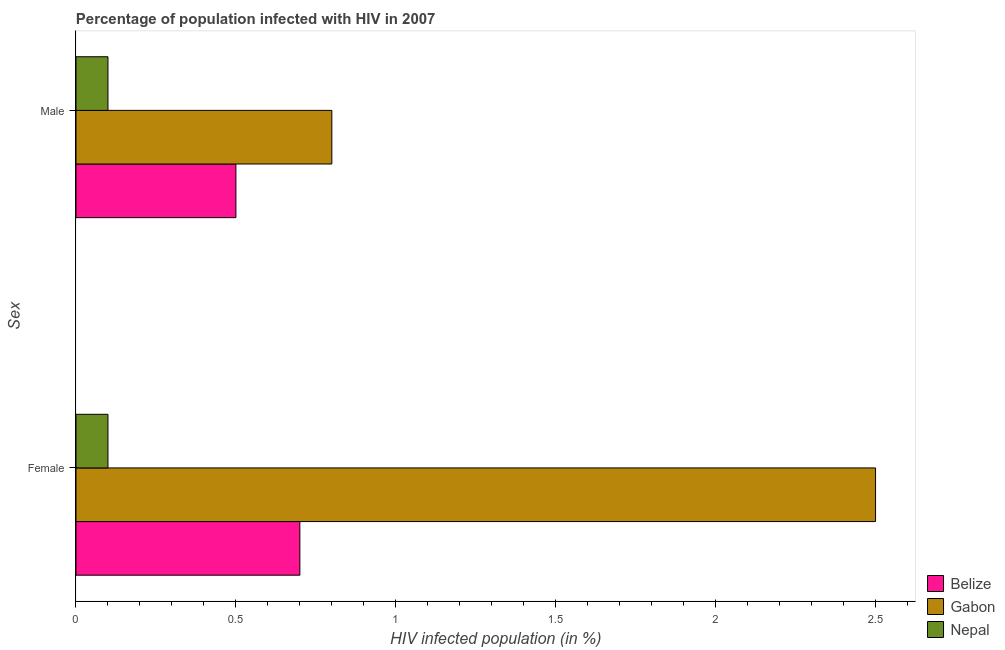How many groups of bars are there?
Your answer should be very brief. 2. Are the number of bars per tick equal to the number of legend labels?
Make the answer very short. Yes. How many bars are there on the 2nd tick from the top?
Offer a very short reply. 3. How many bars are there on the 1st tick from the bottom?
Give a very brief answer. 3. What is the label of the 1st group of bars from the top?
Provide a short and direct response. Male. In which country was the percentage of males who are infected with hiv maximum?
Ensure brevity in your answer.  Gabon. In which country was the percentage of females who are infected with hiv minimum?
Your answer should be compact. Nepal. What is the total percentage of females who are infected with hiv in the graph?
Provide a succinct answer. 3.3. What is the difference between the percentage of males who are infected with hiv in Nepal and that in Belize?
Ensure brevity in your answer.  -0.4. What is the difference between the percentage of females who are infected with hiv in Gabon and the percentage of males who are infected with hiv in Belize?
Make the answer very short. 2. What is the average percentage of males who are infected with hiv per country?
Your response must be concise. 0.47. What is the difference between the percentage of males who are infected with hiv and percentage of females who are infected with hiv in Belize?
Give a very brief answer. -0.2. In how many countries, is the percentage of females who are infected with hiv greater than 1.8 %?
Give a very brief answer. 1. In how many countries, is the percentage of males who are infected with hiv greater than the average percentage of males who are infected with hiv taken over all countries?
Your response must be concise. 2. What does the 2nd bar from the top in Female represents?
Make the answer very short. Gabon. What does the 1st bar from the bottom in Male represents?
Give a very brief answer. Belize. How many bars are there?
Provide a short and direct response. 6. Are all the bars in the graph horizontal?
Ensure brevity in your answer.  Yes. What is the difference between two consecutive major ticks on the X-axis?
Your response must be concise. 0.5. Are the values on the major ticks of X-axis written in scientific E-notation?
Give a very brief answer. No. Does the graph contain grids?
Your answer should be compact. No. Where does the legend appear in the graph?
Give a very brief answer. Bottom right. What is the title of the graph?
Offer a terse response. Percentage of population infected with HIV in 2007. What is the label or title of the X-axis?
Your answer should be compact. HIV infected population (in %). What is the label or title of the Y-axis?
Offer a very short reply. Sex. What is the HIV infected population (in %) of Gabon in Female?
Make the answer very short. 2.5. What is the HIV infected population (in %) in Nepal in Female?
Make the answer very short. 0.1. Across all Sex, what is the maximum HIV infected population (in %) of Gabon?
Your response must be concise. 2.5. Across all Sex, what is the maximum HIV infected population (in %) of Nepal?
Your response must be concise. 0.1. Across all Sex, what is the minimum HIV infected population (in %) of Nepal?
Ensure brevity in your answer.  0.1. What is the total HIV infected population (in %) in Belize in the graph?
Offer a terse response. 1.2. What is the total HIV infected population (in %) of Nepal in the graph?
Your answer should be compact. 0.2. What is the difference between the HIV infected population (in %) of Belize in Female and that in Male?
Keep it short and to the point. 0.2. What is the difference between the HIV infected population (in %) of Gabon in Female and that in Male?
Provide a succinct answer. 1.7. What is the difference between the HIV infected population (in %) of Nepal in Female and that in Male?
Your answer should be compact. 0. What is the average HIV infected population (in %) in Gabon per Sex?
Give a very brief answer. 1.65. What is the average HIV infected population (in %) of Nepal per Sex?
Offer a very short reply. 0.1. What is the difference between the HIV infected population (in %) in Gabon and HIV infected population (in %) in Nepal in Female?
Provide a short and direct response. 2.4. What is the ratio of the HIV infected population (in %) in Belize in Female to that in Male?
Offer a very short reply. 1.4. What is the ratio of the HIV infected population (in %) of Gabon in Female to that in Male?
Your response must be concise. 3.12. What is the difference between the highest and the lowest HIV infected population (in %) of Belize?
Keep it short and to the point. 0.2. What is the difference between the highest and the lowest HIV infected population (in %) in Nepal?
Offer a terse response. 0. 